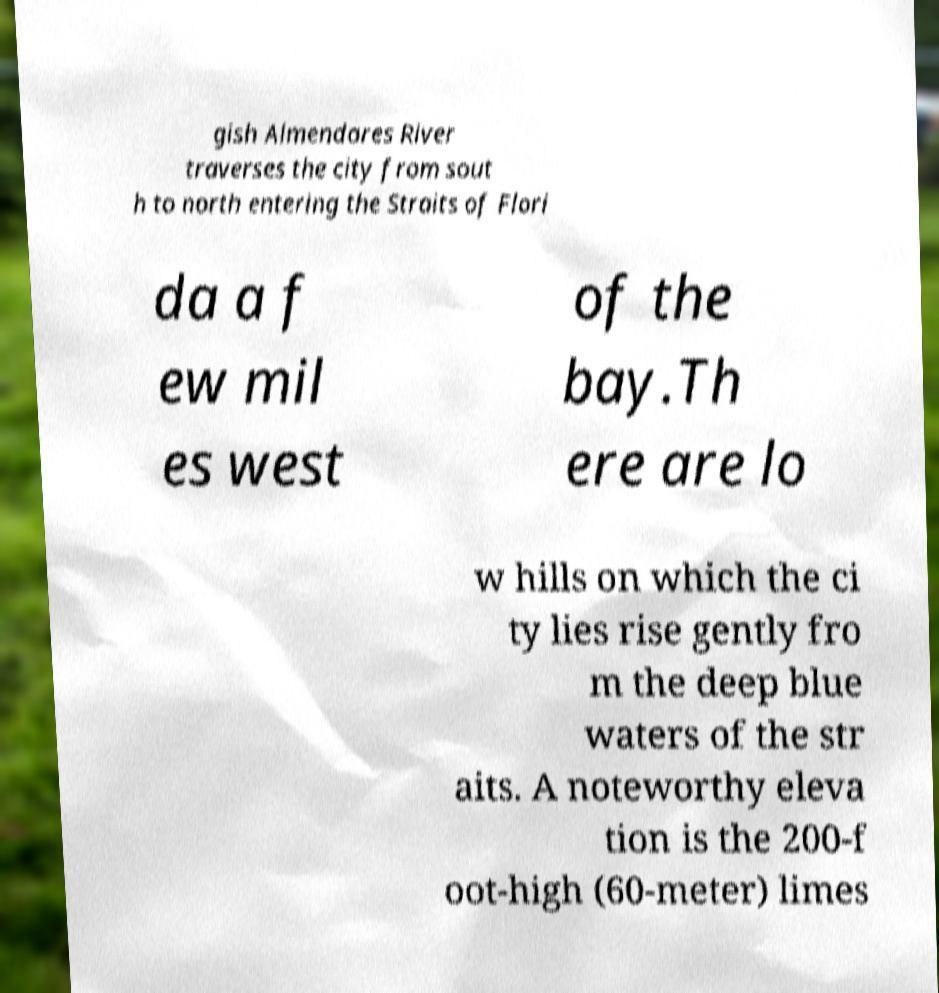Could you extract and type out the text from this image? gish Almendares River traverses the city from sout h to north entering the Straits of Flori da a f ew mil es west of the bay.Th ere are lo w hills on which the ci ty lies rise gently fro m the deep blue waters of the str aits. A noteworthy eleva tion is the 200-f oot-high (60-meter) limes 